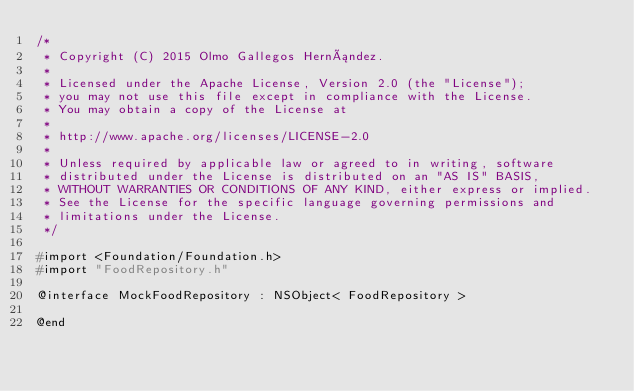Convert code to text. <code><loc_0><loc_0><loc_500><loc_500><_C_>/*
 * Copyright (C) 2015 Olmo Gallegos Hernández.
 *
 * Licensed under the Apache License, Version 2.0 (the "License");
 * you may not use this file except in compliance with the License.
 * You may obtain a copy of the License at
 *
 * http://www.apache.org/licenses/LICENSE-2.0
 *
 * Unless required by applicable law or agreed to in writing, software
 * distributed under the License is distributed on an "AS IS" BASIS,
 * WITHOUT WARRANTIES OR CONDITIONS OF ANY KIND, either express or implied.
 * See the License for the specific language governing permissions and
 * limitations under the License.
 */

#import <Foundation/Foundation.h>
#import "FoodRepository.h"

@interface MockFoodRepository : NSObject< FoodRepository >

@end
</code> 